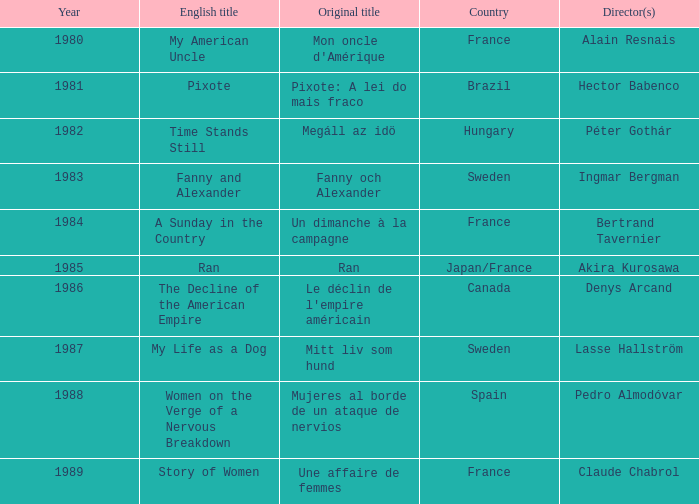What was the original title that was directed by Alain Resnais in France before 1986? Mon oncle d'Amérique. 